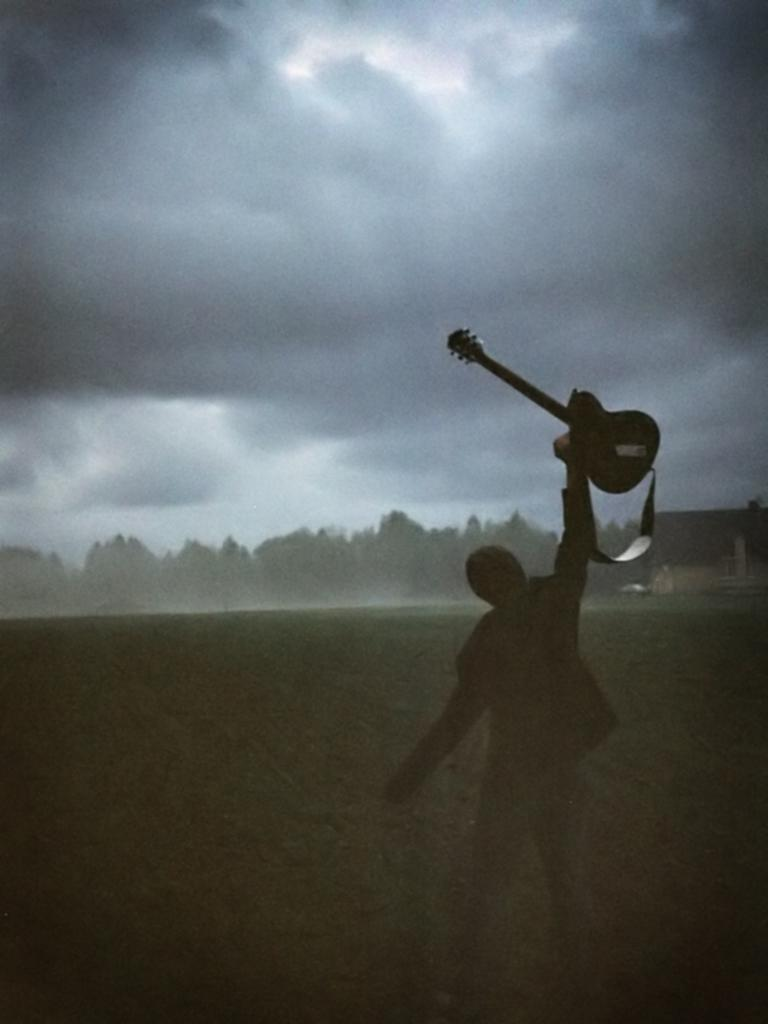What is the main subject of the image? There is a person in the image. What is the person doing in the image? The person is standing and holding a guitar with his hand. What can be seen in the sky in the image? There are clouds in the sky. Can you tell me how many tomatoes are on the door in the image? There is no door or tomatoes present in the image. What type of argument is the person having with the guitar in the image? There is no argument depicted in the image; the person is simply holding a guitar. 